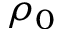Convert formula to latex. <formula><loc_0><loc_0><loc_500><loc_500>\rho _ { 0 }</formula> 